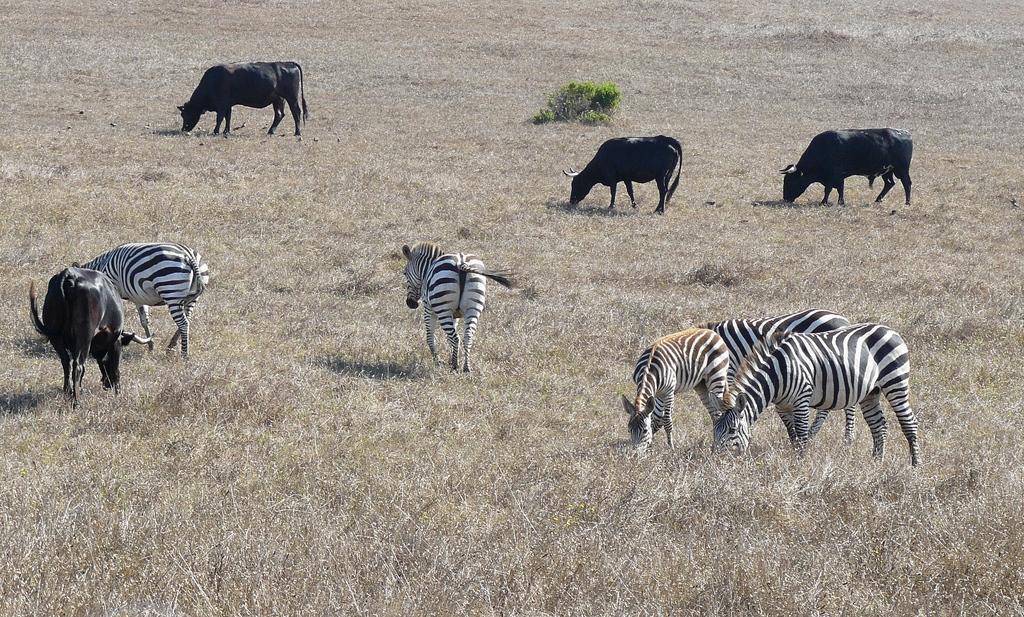In one or two sentences, can you explain what this image depicts? In this image there are zebras and cattle standing on the ground and grazing. There are plants and grass on the ground. 